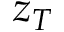<formula> <loc_0><loc_0><loc_500><loc_500>z _ { T }</formula> 